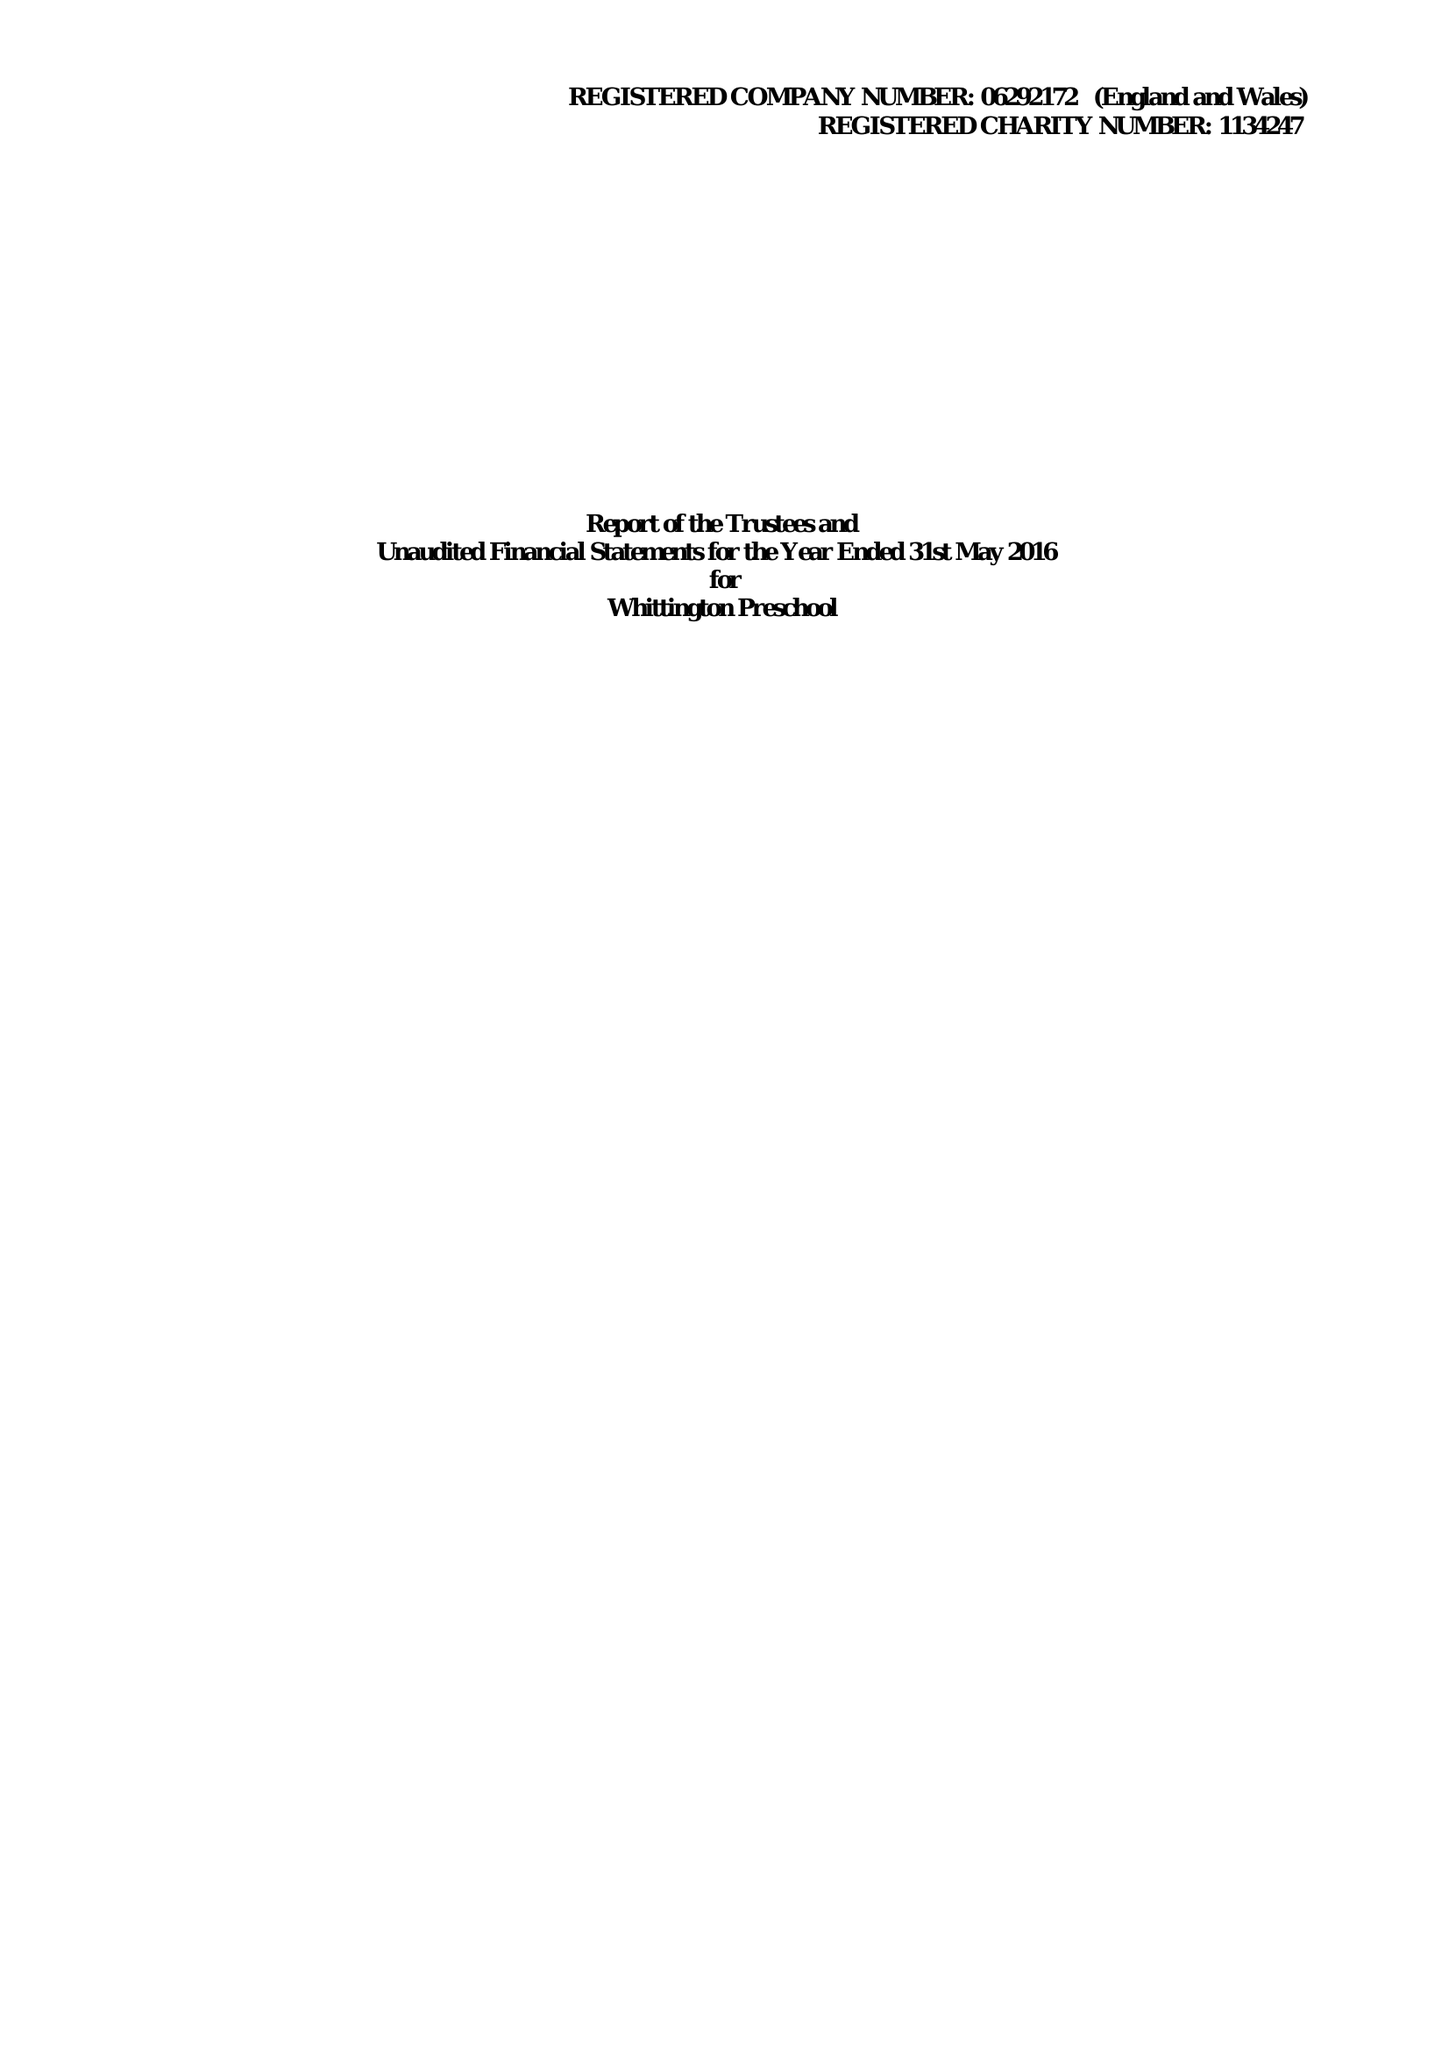What is the value for the charity_name?
Answer the question using a single word or phrase. Whittington Preschool 